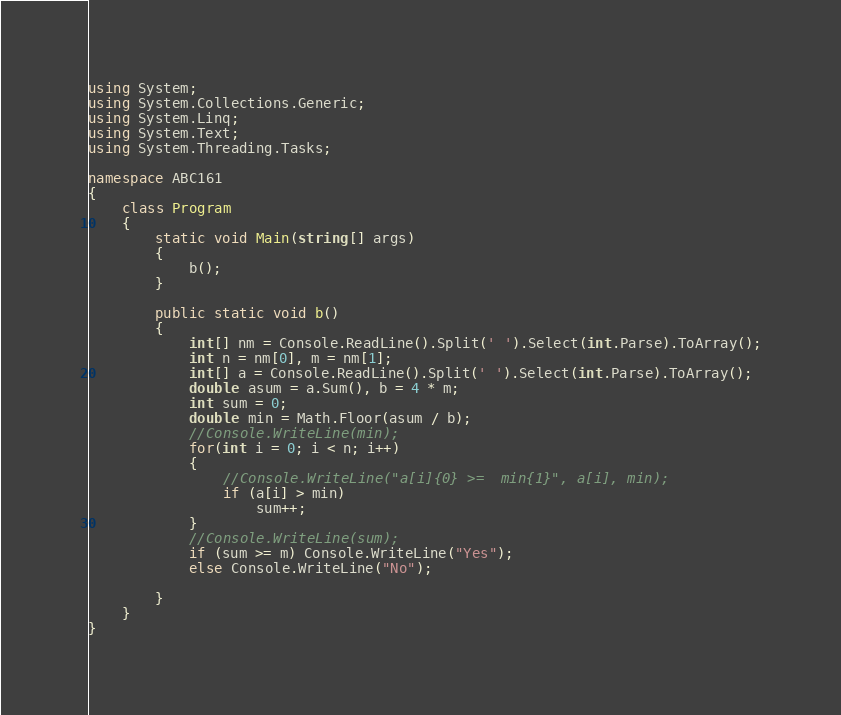<code> <loc_0><loc_0><loc_500><loc_500><_C#_>using System;
using System.Collections.Generic;
using System.Linq;
using System.Text;
using System.Threading.Tasks;

namespace ABC161
{
    class Program
    {
        static void Main(string[] args)
        {
            b();
        }

        public static void b()
        {
            int[] nm = Console.ReadLine().Split(' ').Select(int.Parse).ToArray();
            int n = nm[0], m = nm[1];
            int[] a = Console.ReadLine().Split(' ').Select(int.Parse).ToArray();
            double asum = a.Sum(), b = 4 * m;
            int sum = 0;
            double min = Math.Floor(asum / b);
            //Console.WriteLine(min);
            for(int i = 0; i < n; i++)
            {
                //Console.WriteLine("a[i]{0} >=  min{1}", a[i], min);
                if (a[i] > min)
                    sum++;
            }
            //Console.WriteLine(sum);
            if (sum >= m) Console.WriteLine("Yes");
            else Console.WriteLine("No");
            
        }
    }
}
</code> 